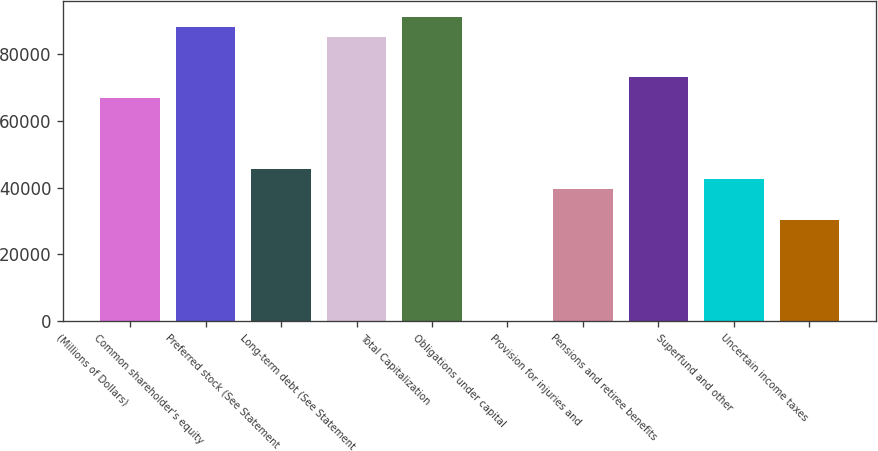<chart> <loc_0><loc_0><loc_500><loc_500><bar_chart><fcel>(Millions of Dollars)<fcel>Common shareholder's equity<fcel>Preferred stock (See Statement<fcel>Long-term debt (See Statement<fcel>Total Capitalization<fcel>Obligations under capital<fcel>Provision for injuries and<fcel>Pensions and retiree benefits<fcel>Superfund and other<fcel>Uncertain income taxes<nl><fcel>66892.6<fcel>88171.2<fcel>45614<fcel>85131.4<fcel>91211<fcel>17<fcel>39534.4<fcel>72972.2<fcel>42574.2<fcel>30415<nl></chart> 